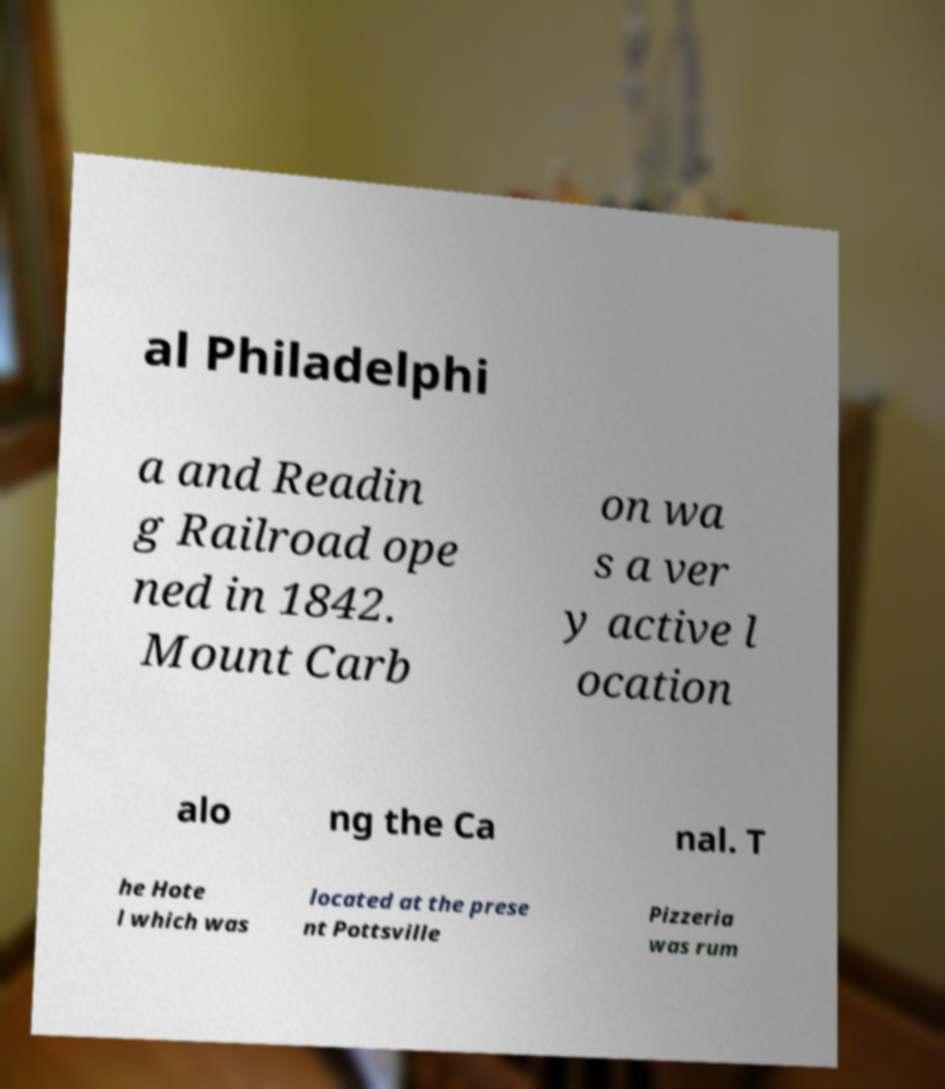Please read and relay the text visible in this image. What does it say? al Philadelphi a and Readin g Railroad ope ned in 1842. Mount Carb on wa s a ver y active l ocation alo ng the Ca nal. T he Hote l which was located at the prese nt Pottsville Pizzeria was rum 